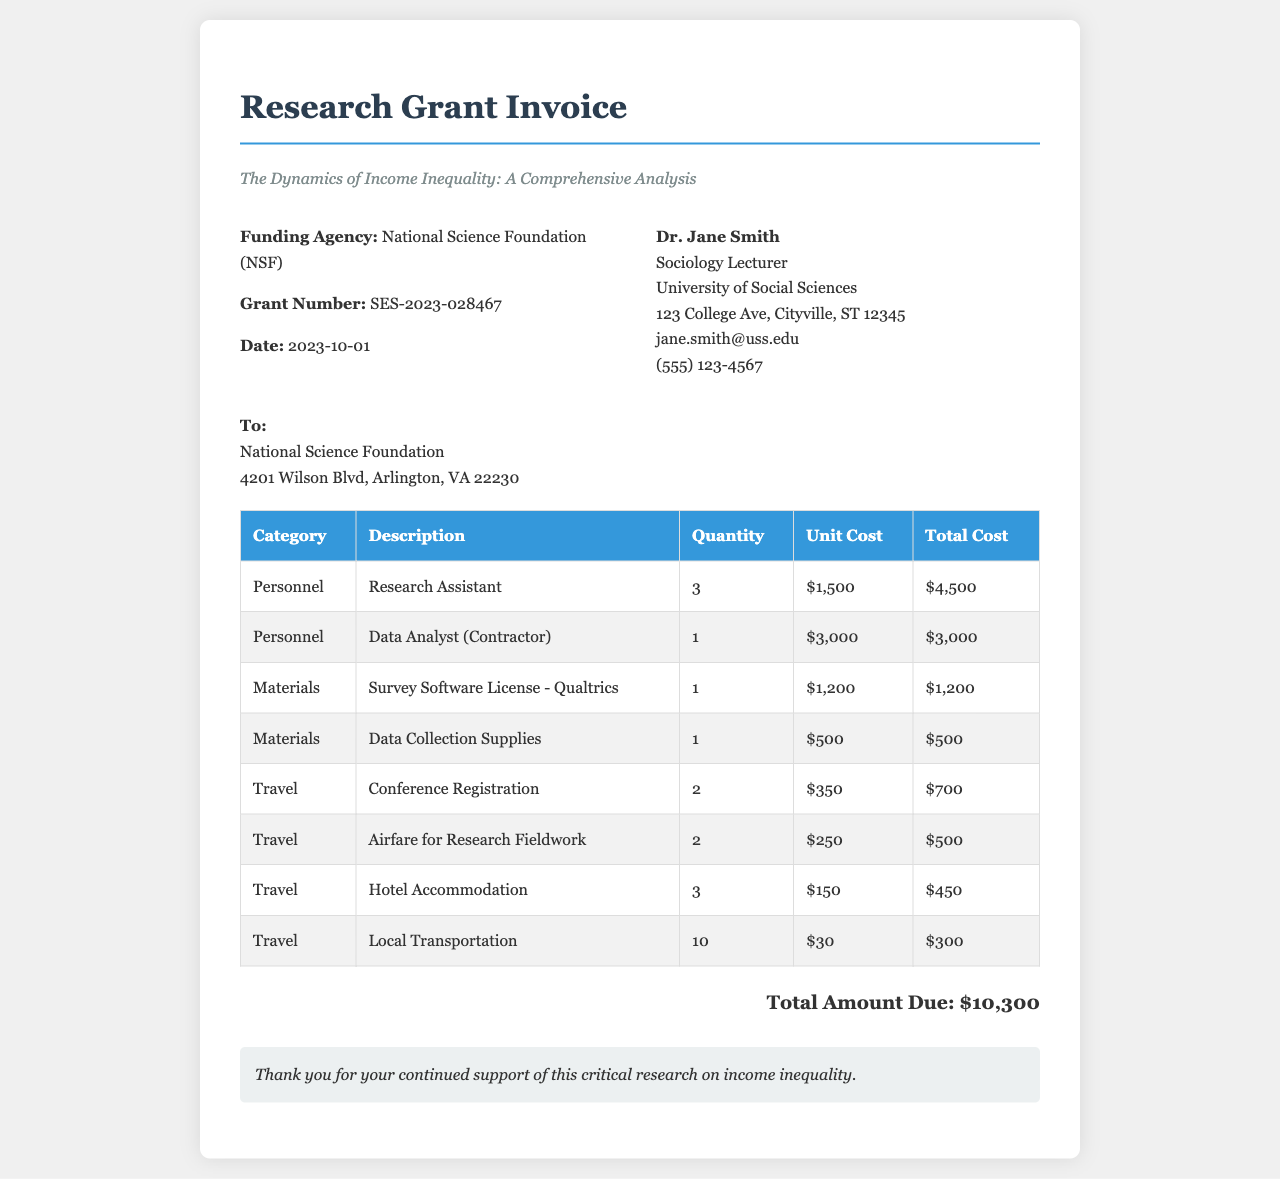What is the funding agency? The funding agency is mentioned in the document as the entity that provided the financial support for the research, which is the National Science Foundation.
Answer: National Science Foundation (NSF) What is the grant number? The grant number is a specific identifier used for tracking the funding, which in this case is listed in the document as SES-2023-028467.
Answer: SES-2023-028467 What is the total amount due on this invoice? The total amount due is the final sum calculated from all listed costs in the invoice, which equals $10,300.
Answer: $10,300 How many research assistants are included in the personnel expenses? The document specifies the number of research assistants included in the personnel expenses, which is detailed in the personnel costs section.
Answer: 3 What is the unit cost of the survey software license? The unit cost for the survey software license is explicitly mentioned in the materials section of the invoice, which is $1,200.
Answer: $1,200 What is the quantity of travel expenses associated with local transportation? The invoice lists the quantity of travel expenses for local transportation in the travel section, amounting to 10.
Answer: 10 Which category has the highest total cost? By reviewing the total costs for each category, one can determine which category has the highest total, indicating it is personnel expenses.
Answer: Personnel How many hotel accommodations are billed? The quantity of hotel accommodations is specified in the travel expenses section of the invoice, noted to be 3.
Answer: 3 What is the description of the item with the highest unit cost? The item with the highest unit cost can be identified from the materials section, which lists the survey software license as the most expensive item.
Answer: Survey Software License - Qualtrics 